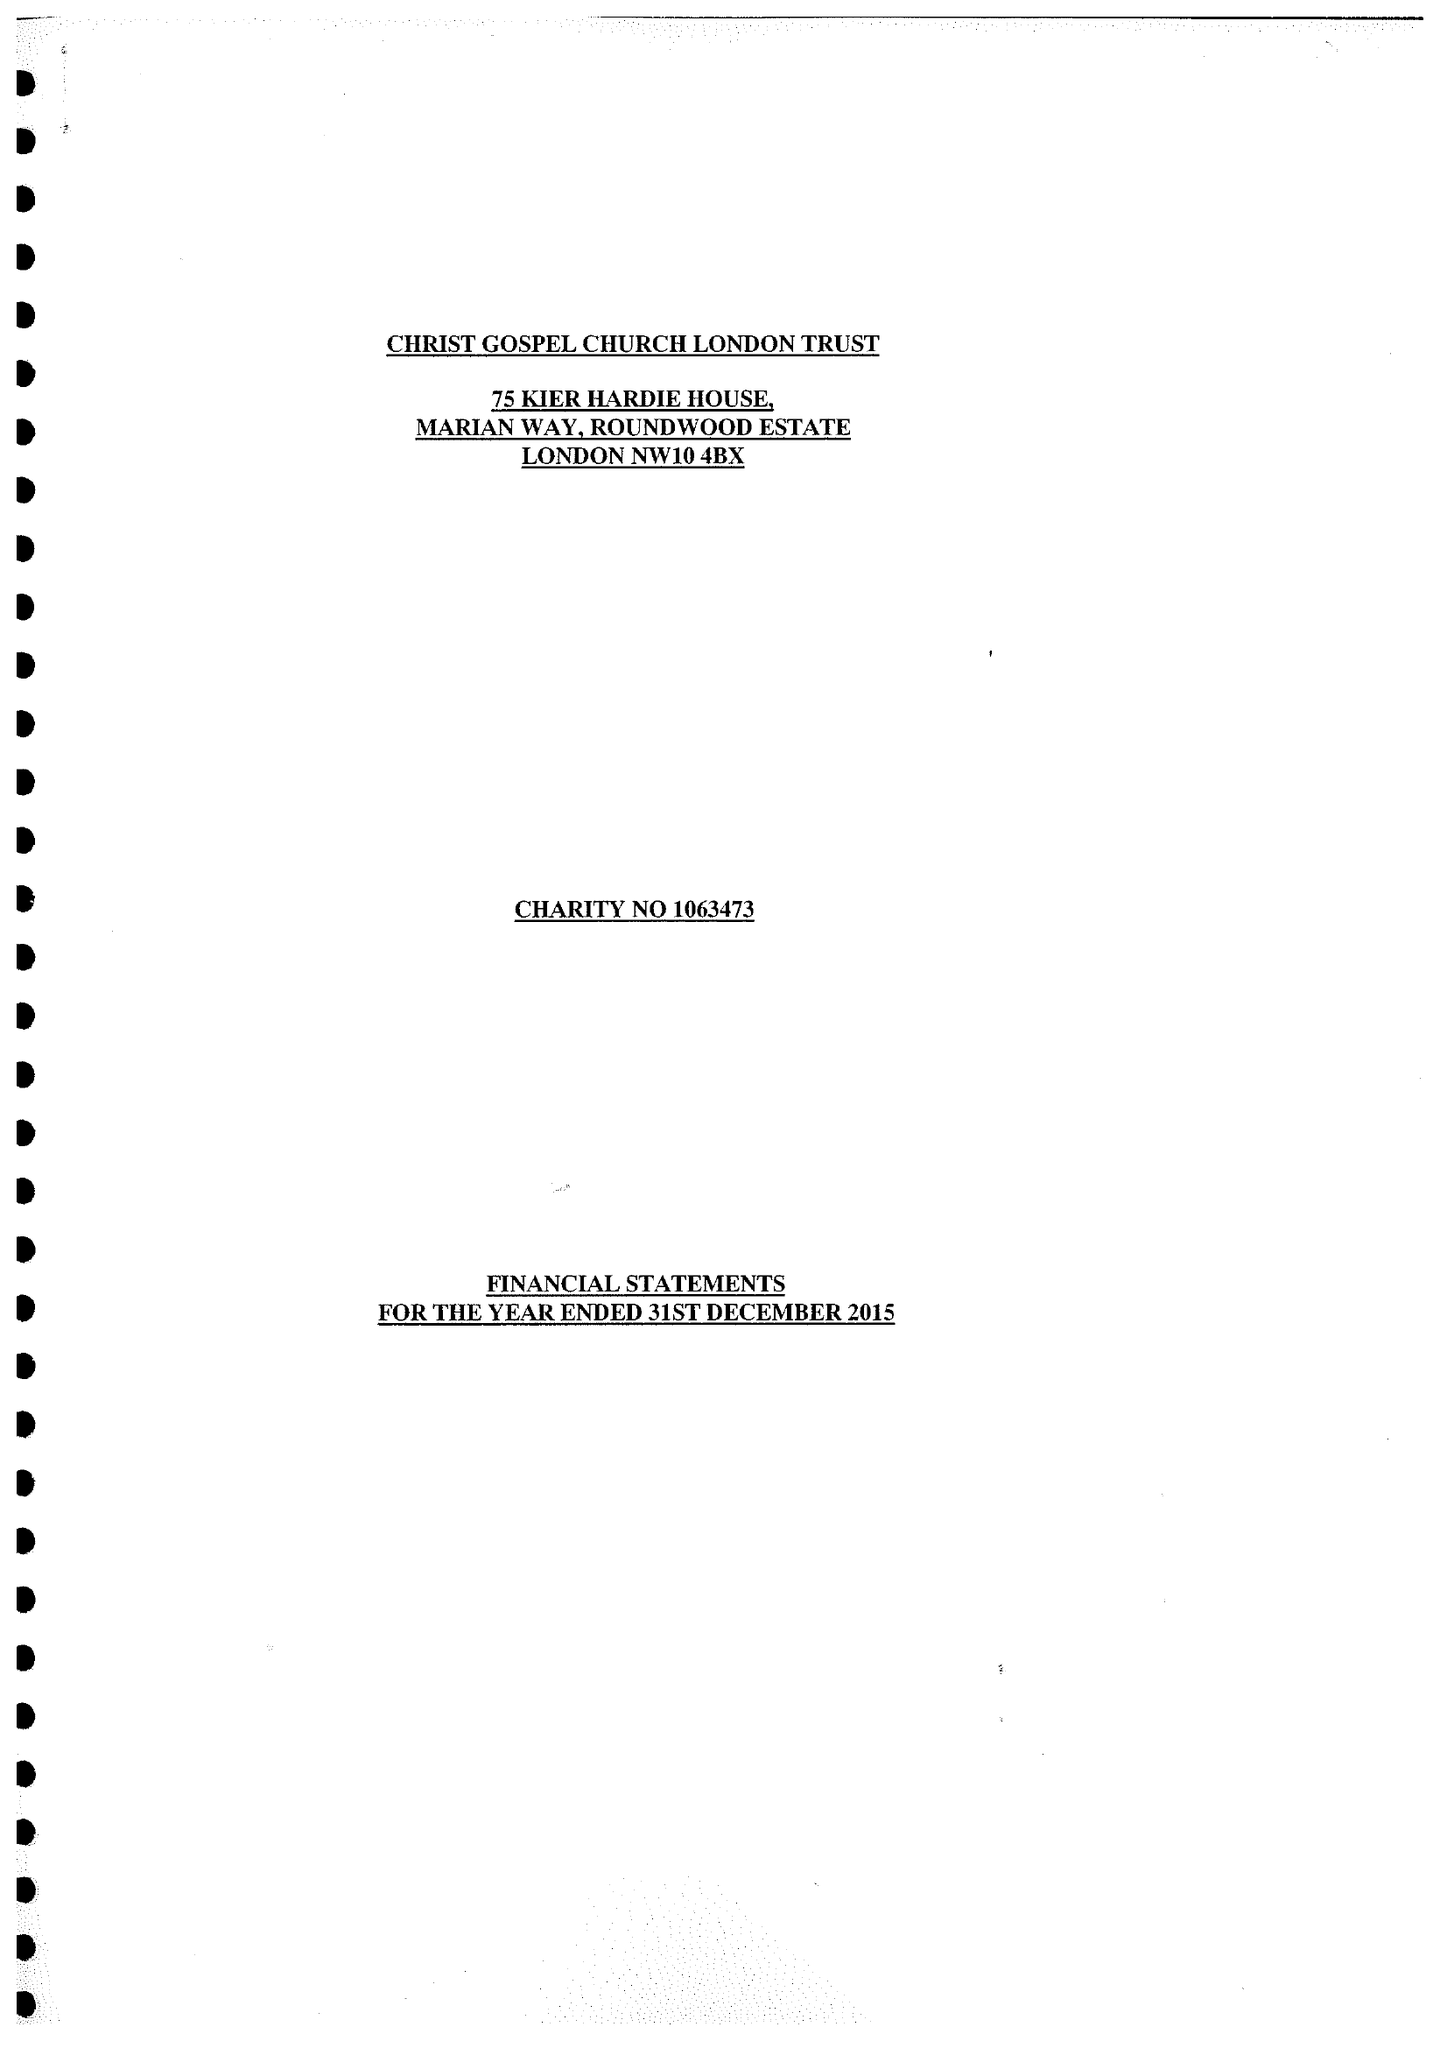What is the value for the address__postcode?
Answer the question using a single word or phrase. NW10 4BX 